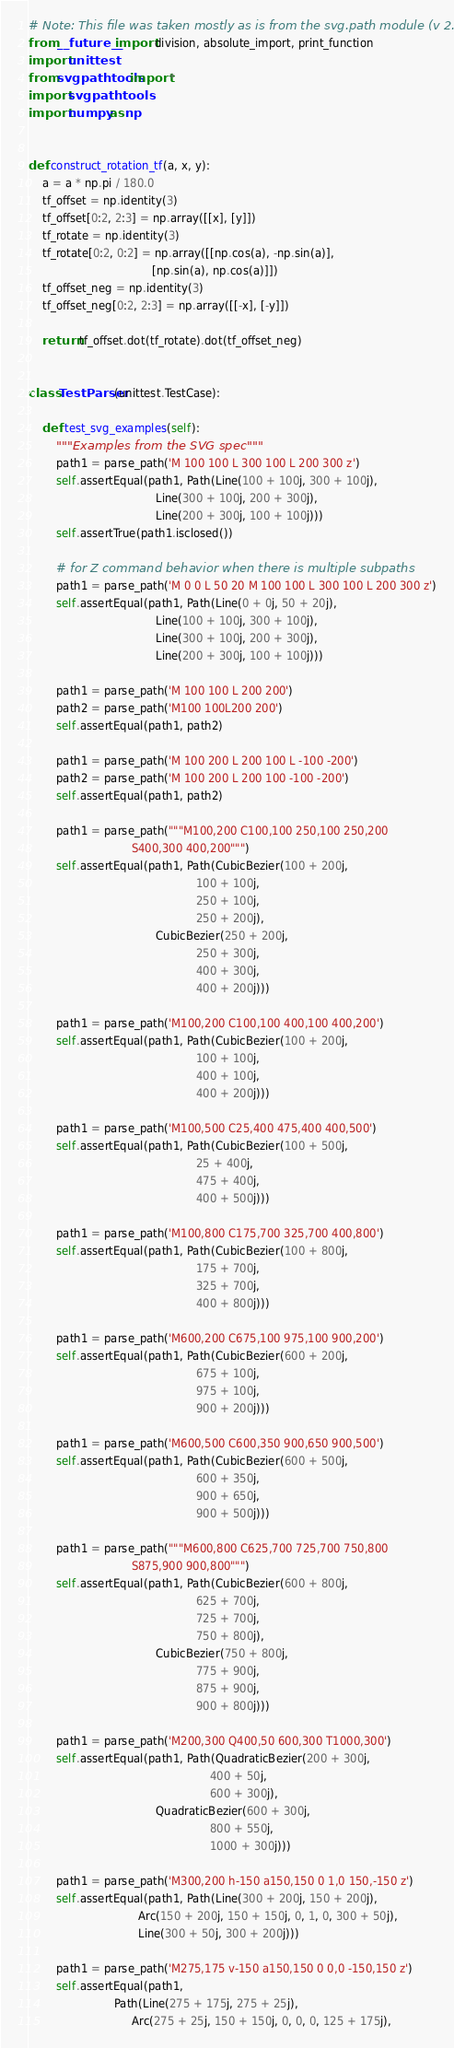<code> <loc_0><loc_0><loc_500><loc_500><_Python_># Note: This file was taken mostly as is from the svg.path module (v 2.0)
from __future__ import division, absolute_import, print_function
import unittest
from svgpathtools import *
import svgpathtools
import numpy as np


def construct_rotation_tf(a, x, y):
    a = a * np.pi / 180.0
    tf_offset = np.identity(3)
    tf_offset[0:2, 2:3] = np.array([[x], [y]])
    tf_rotate = np.identity(3)
    tf_rotate[0:2, 0:2] = np.array([[np.cos(a), -np.sin(a)],
                                    [np.sin(a), np.cos(a)]])
    tf_offset_neg = np.identity(3)
    tf_offset_neg[0:2, 2:3] = np.array([[-x], [-y]])

    return tf_offset.dot(tf_rotate).dot(tf_offset_neg)


class TestParser(unittest.TestCase):

    def test_svg_examples(self):
        """Examples from the SVG spec"""
        path1 = parse_path('M 100 100 L 300 100 L 200 300 z')
        self.assertEqual(path1, Path(Line(100 + 100j, 300 + 100j),
                                     Line(300 + 100j, 200 + 300j),
                                     Line(200 + 300j, 100 + 100j)))
        self.assertTrue(path1.isclosed())

        # for Z command behavior when there is multiple subpaths
        path1 = parse_path('M 0 0 L 50 20 M 100 100 L 300 100 L 200 300 z')
        self.assertEqual(path1, Path(Line(0 + 0j, 50 + 20j),
                                     Line(100 + 100j, 300 + 100j),
                                     Line(300 + 100j, 200 + 300j),
                                     Line(200 + 300j, 100 + 100j)))

        path1 = parse_path('M 100 100 L 200 200')
        path2 = parse_path('M100 100L200 200')
        self.assertEqual(path1, path2)

        path1 = parse_path('M 100 200 L 200 100 L -100 -200')
        path2 = parse_path('M 100 200 L 200 100 -100 -200')
        self.assertEqual(path1, path2)

        path1 = parse_path("""M100,200 C100,100 250,100 250,200
                              S400,300 400,200""")
        self.assertEqual(path1, Path(CubicBezier(100 + 200j,
                                                 100 + 100j,
                                                 250 + 100j,
                                                 250 + 200j),
                                     CubicBezier(250 + 200j,
                                                 250 + 300j,
                                                 400 + 300j,
                                                 400 + 200j)))

        path1 = parse_path('M100,200 C100,100 400,100 400,200')
        self.assertEqual(path1, Path(CubicBezier(100 + 200j,
                                                 100 + 100j,
                                                 400 + 100j,
                                                 400 + 200j)))

        path1 = parse_path('M100,500 C25,400 475,400 400,500')
        self.assertEqual(path1, Path(CubicBezier(100 + 500j,
                                                 25 + 400j,
                                                 475 + 400j,
                                                 400 + 500j)))

        path1 = parse_path('M100,800 C175,700 325,700 400,800')
        self.assertEqual(path1, Path(CubicBezier(100 + 800j,
                                                 175 + 700j,
                                                 325 + 700j,
                                                 400 + 800j)))

        path1 = parse_path('M600,200 C675,100 975,100 900,200')
        self.assertEqual(path1, Path(CubicBezier(600 + 200j,
                                                 675 + 100j,
                                                 975 + 100j,
                                                 900 + 200j)))

        path1 = parse_path('M600,500 C600,350 900,650 900,500')
        self.assertEqual(path1, Path(CubicBezier(600 + 500j,
                                                 600 + 350j,
                                                 900 + 650j,
                                                 900 + 500j)))

        path1 = parse_path("""M600,800 C625,700 725,700 750,800
                              S875,900 900,800""")
        self.assertEqual(path1, Path(CubicBezier(600 + 800j,
                                                 625 + 700j,
                                                 725 + 700j,
                                                 750 + 800j),
                                     CubicBezier(750 + 800j,
                                                 775 + 900j,
                                                 875 + 900j,
                                                 900 + 800j)))

        path1 = parse_path('M200,300 Q400,50 600,300 T1000,300')
        self.assertEqual(path1, Path(QuadraticBezier(200 + 300j,
                                                     400 + 50j,
                                                     600 + 300j),
                                     QuadraticBezier(600 + 300j,
                                                     800 + 550j,
                                                     1000 + 300j)))

        path1 = parse_path('M300,200 h-150 a150,150 0 1,0 150,-150 z')
        self.assertEqual(path1, Path(Line(300 + 200j, 150 + 200j),
                                Arc(150 + 200j, 150 + 150j, 0, 1, 0, 300 + 50j),
                                Line(300 + 50j, 300 + 200j)))

        path1 = parse_path('M275,175 v-150 a150,150 0 0,0 -150,150 z')
        self.assertEqual(path1,
                         Path(Line(275 + 175j, 275 + 25j),
                              Arc(275 + 25j, 150 + 150j, 0, 0, 0, 125 + 175j),</code> 